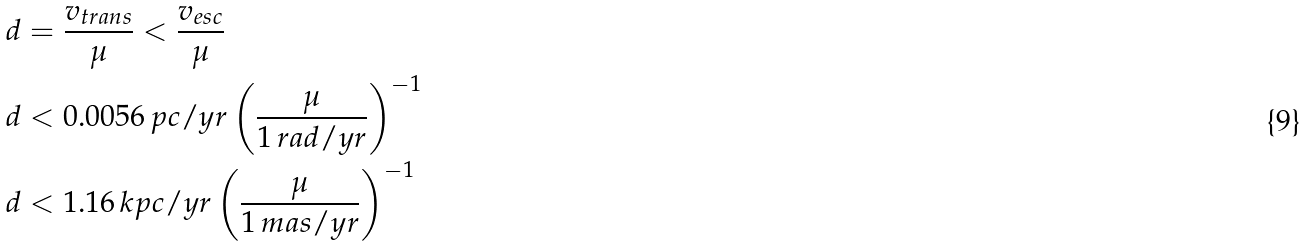<formula> <loc_0><loc_0><loc_500><loc_500>d & = \frac { v _ { t r a n s } } { \mu } < \frac { v _ { e s c } } { \mu } \\ d & < 0 . 0 0 5 6 \, p c / y r \left ( \frac { \mu } { 1 \, r a d / y r } \right ) ^ { - 1 } \\ d & < 1 . 1 6 \, k p c / y r \left ( \frac { \mu } { 1 \, m a s / y r } \right ) ^ { - 1 }</formula> 